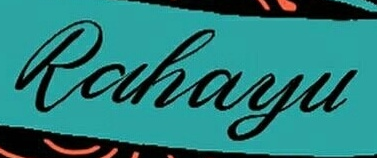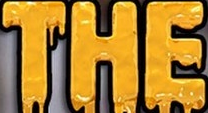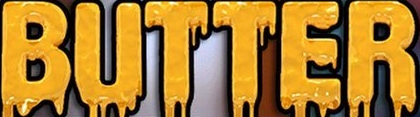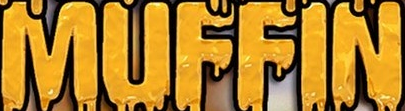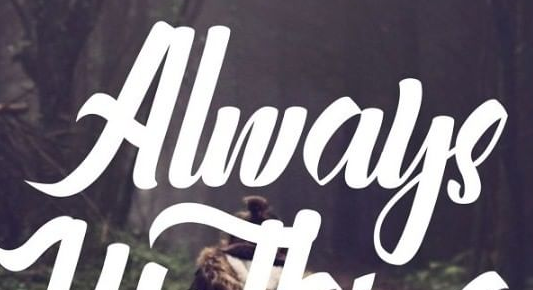What text appears in these images from left to right, separated by a semicolon? Rahayu; THE; BUTTER; MUFFIN; Always 